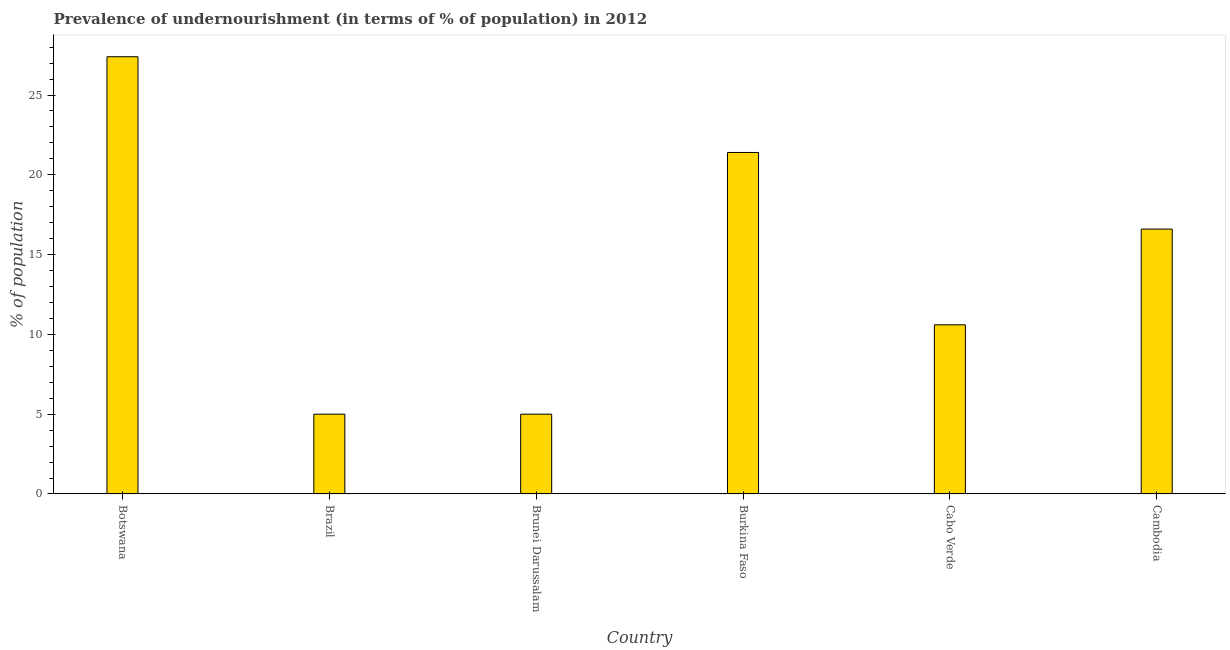Does the graph contain any zero values?
Provide a succinct answer. No. Does the graph contain grids?
Keep it short and to the point. No. What is the title of the graph?
Your answer should be compact. Prevalence of undernourishment (in terms of % of population) in 2012. What is the label or title of the X-axis?
Offer a terse response. Country. What is the label or title of the Y-axis?
Offer a terse response. % of population. What is the percentage of undernourished population in Brazil?
Provide a succinct answer. 5. Across all countries, what is the maximum percentage of undernourished population?
Make the answer very short. 27.4. Across all countries, what is the minimum percentage of undernourished population?
Make the answer very short. 5. In which country was the percentage of undernourished population maximum?
Provide a short and direct response. Botswana. What is the average percentage of undernourished population per country?
Provide a succinct answer. 14.33. What is the median percentage of undernourished population?
Ensure brevity in your answer.  13.6. In how many countries, is the percentage of undernourished population greater than 27 %?
Offer a terse response. 1. What is the ratio of the percentage of undernourished population in Botswana to that in Brunei Darussalam?
Your answer should be compact. 5.48. Is the percentage of undernourished population in Cabo Verde less than that in Cambodia?
Give a very brief answer. Yes. Is the difference between the percentage of undernourished population in Botswana and Brunei Darussalam greater than the difference between any two countries?
Offer a terse response. Yes. What is the difference between the highest and the second highest percentage of undernourished population?
Your answer should be compact. 6. Is the sum of the percentage of undernourished population in Brunei Darussalam and Cambodia greater than the maximum percentage of undernourished population across all countries?
Give a very brief answer. No. What is the difference between the highest and the lowest percentage of undernourished population?
Ensure brevity in your answer.  22.4. How many countries are there in the graph?
Your answer should be very brief. 6. What is the % of population of Botswana?
Make the answer very short. 27.4. What is the % of population in Brazil?
Give a very brief answer. 5. What is the % of population of Brunei Darussalam?
Keep it short and to the point. 5. What is the % of population in Burkina Faso?
Offer a terse response. 21.4. What is the % of population of Cabo Verde?
Your response must be concise. 10.6. What is the % of population of Cambodia?
Your answer should be very brief. 16.6. What is the difference between the % of population in Botswana and Brazil?
Offer a terse response. 22.4. What is the difference between the % of population in Botswana and Brunei Darussalam?
Your answer should be very brief. 22.4. What is the difference between the % of population in Brazil and Burkina Faso?
Make the answer very short. -16.4. What is the difference between the % of population in Brazil and Cabo Verde?
Ensure brevity in your answer.  -5.6. What is the difference between the % of population in Brazil and Cambodia?
Give a very brief answer. -11.6. What is the difference between the % of population in Brunei Darussalam and Burkina Faso?
Provide a succinct answer. -16.4. What is the difference between the % of population in Cabo Verde and Cambodia?
Offer a terse response. -6. What is the ratio of the % of population in Botswana to that in Brazil?
Make the answer very short. 5.48. What is the ratio of the % of population in Botswana to that in Brunei Darussalam?
Your response must be concise. 5.48. What is the ratio of the % of population in Botswana to that in Burkina Faso?
Provide a succinct answer. 1.28. What is the ratio of the % of population in Botswana to that in Cabo Verde?
Make the answer very short. 2.58. What is the ratio of the % of population in Botswana to that in Cambodia?
Ensure brevity in your answer.  1.65. What is the ratio of the % of population in Brazil to that in Burkina Faso?
Provide a succinct answer. 0.23. What is the ratio of the % of population in Brazil to that in Cabo Verde?
Provide a short and direct response. 0.47. What is the ratio of the % of population in Brazil to that in Cambodia?
Keep it short and to the point. 0.3. What is the ratio of the % of population in Brunei Darussalam to that in Burkina Faso?
Your answer should be very brief. 0.23. What is the ratio of the % of population in Brunei Darussalam to that in Cabo Verde?
Your answer should be compact. 0.47. What is the ratio of the % of population in Brunei Darussalam to that in Cambodia?
Make the answer very short. 0.3. What is the ratio of the % of population in Burkina Faso to that in Cabo Verde?
Offer a very short reply. 2.02. What is the ratio of the % of population in Burkina Faso to that in Cambodia?
Give a very brief answer. 1.29. What is the ratio of the % of population in Cabo Verde to that in Cambodia?
Give a very brief answer. 0.64. 